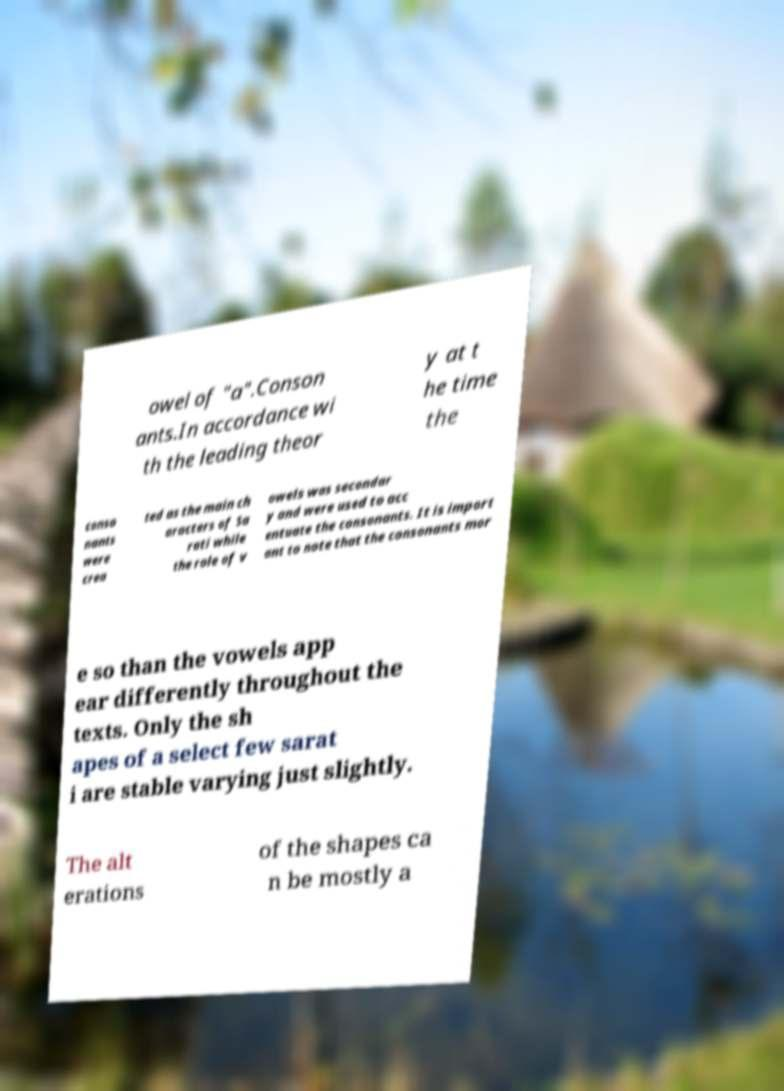Please identify and transcribe the text found in this image. owel of "a".Conson ants.In accordance wi th the leading theor y at t he time the conso nants were crea ted as the main ch aracters of Sa rati while the role of v owels was secondar y and were used to acc entuate the consonants. It is import ant to note that the consonants mor e so than the vowels app ear differently throughout the texts. Only the sh apes of a select few sarat i are stable varying just slightly. The alt erations of the shapes ca n be mostly a 